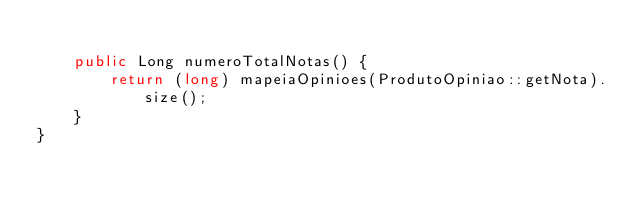Convert code to text. <code><loc_0><loc_0><loc_500><loc_500><_Java_>
    public Long numeroTotalNotas() {
        return (long) mapeiaOpinioes(ProdutoOpiniao::getNota).size();
    }
}
</code> 